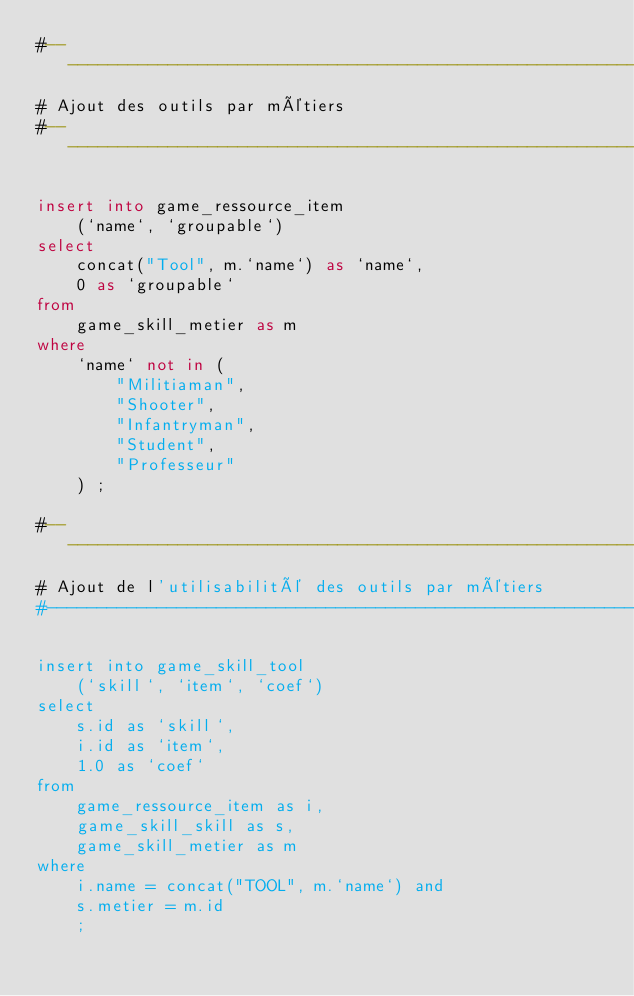Convert code to text. <code><loc_0><loc_0><loc_500><loc_500><_SQL_>#------------------------------------------------------------------------------
# Ajout des outils par métiers
#------------------------------------------------------------------------------

insert into game_ressource_item
    (`name`, `groupable`)
select
    concat("Tool", m.`name`) as `name`,
    0 as `groupable`
from
    game_skill_metier as m
where
    `name` not in (
        "Militiaman",
        "Shooter",
        "Infantryman",
        "Student",
        "Professeur"
    ) ;

#------------------------------------------------------------------------------
# Ajout de l'utilisabilité des outils par métiers
#------------------------------------------------------------------------------

insert into game_skill_tool
    (`skill`, `item`, `coef`)
select
    s.id as `skill`,
    i.id as `item`,
    1.0 as `coef`
from
    game_ressource_item as i,
    game_skill_skill as s,
    game_skill_metier as m
where
    i.name = concat("TOOL", m.`name`) and
    s.metier = m.id
    ;
</code> 